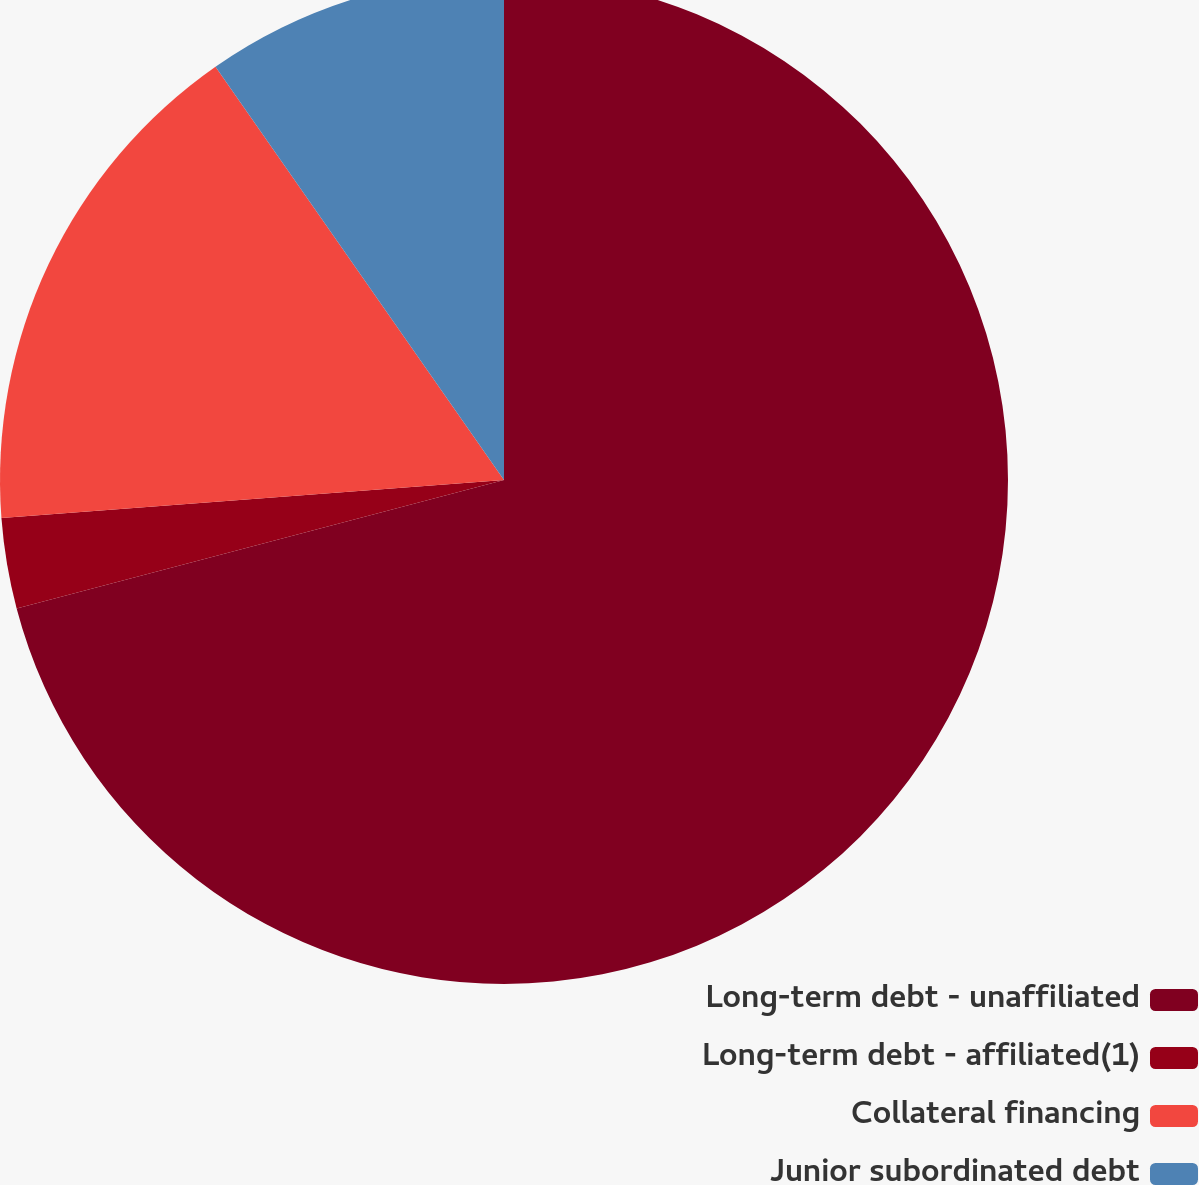Convert chart. <chart><loc_0><loc_0><loc_500><loc_500><pie_chart><fcel>Long-term debt - unaffiliated<fcel>Long-term debt - affiliated(1)<fcel>Collateral financing<fcel>Junior subordinated debt<nl><fcel>70.9%<fcel>2.9%<fcel>16.5%<fcel>9.7%<nl></chart> 